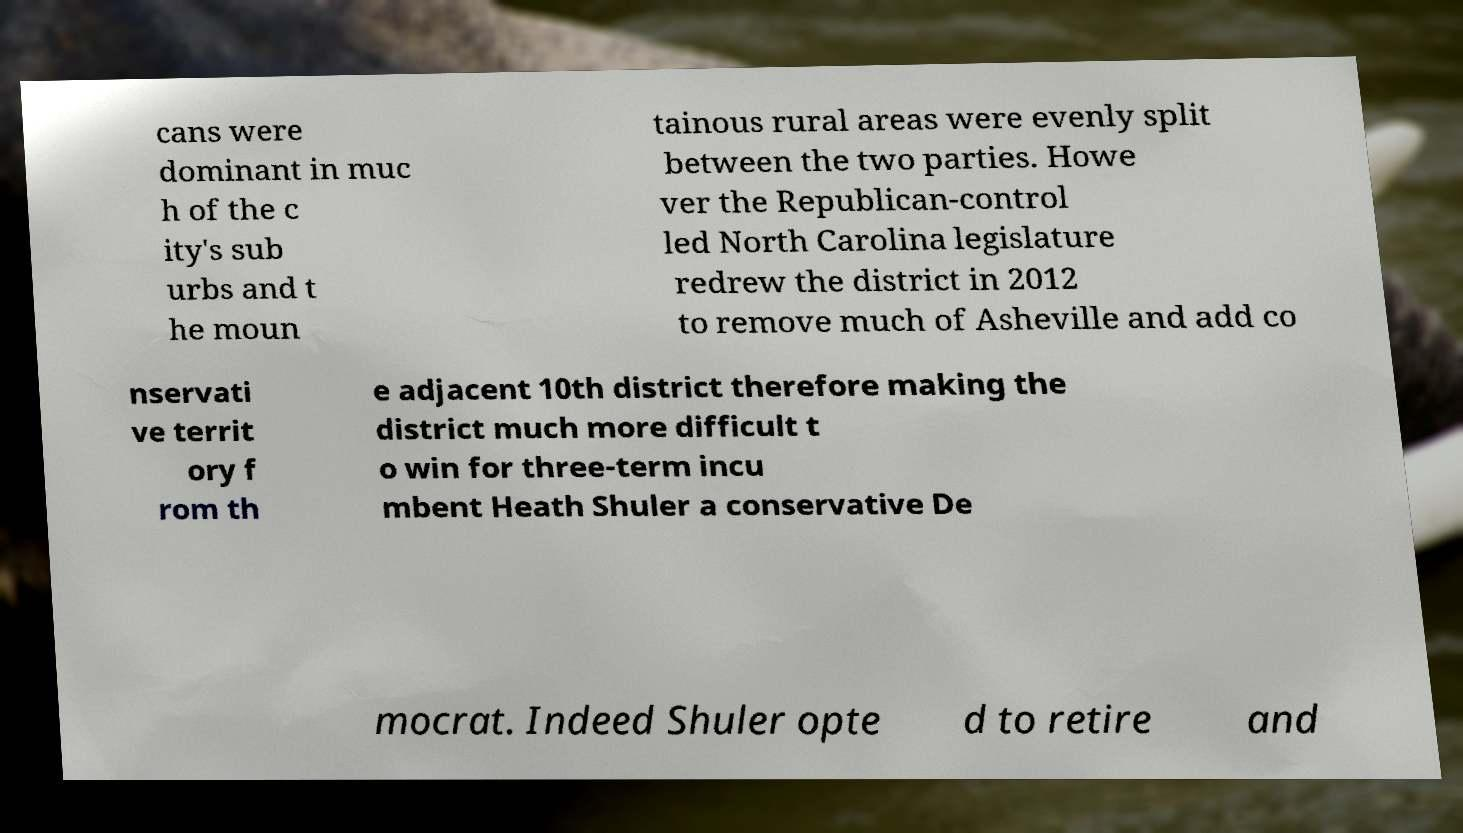Can you accurately transcribe the text from the provided image for me? cans were dominant in muc h of the c ity's sub urbs and t he moun tainous rural areas were evenly split between the two parties. Howe ver the Republican-control led North Carolina legislature redrew the district in 2012 to remove much of Asheville and add co nservati ve territ ory f rom th e adjacent 10th district therefore making the district much more difficult t o win for three-term incu mbent Heath Shuler a conservative De mocrat. Indeed Shuler opte d to retire and 